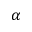Convert formula to latex. <formula><loc_0><loc_0><loc_500><loc_500>\alpha</formula> 